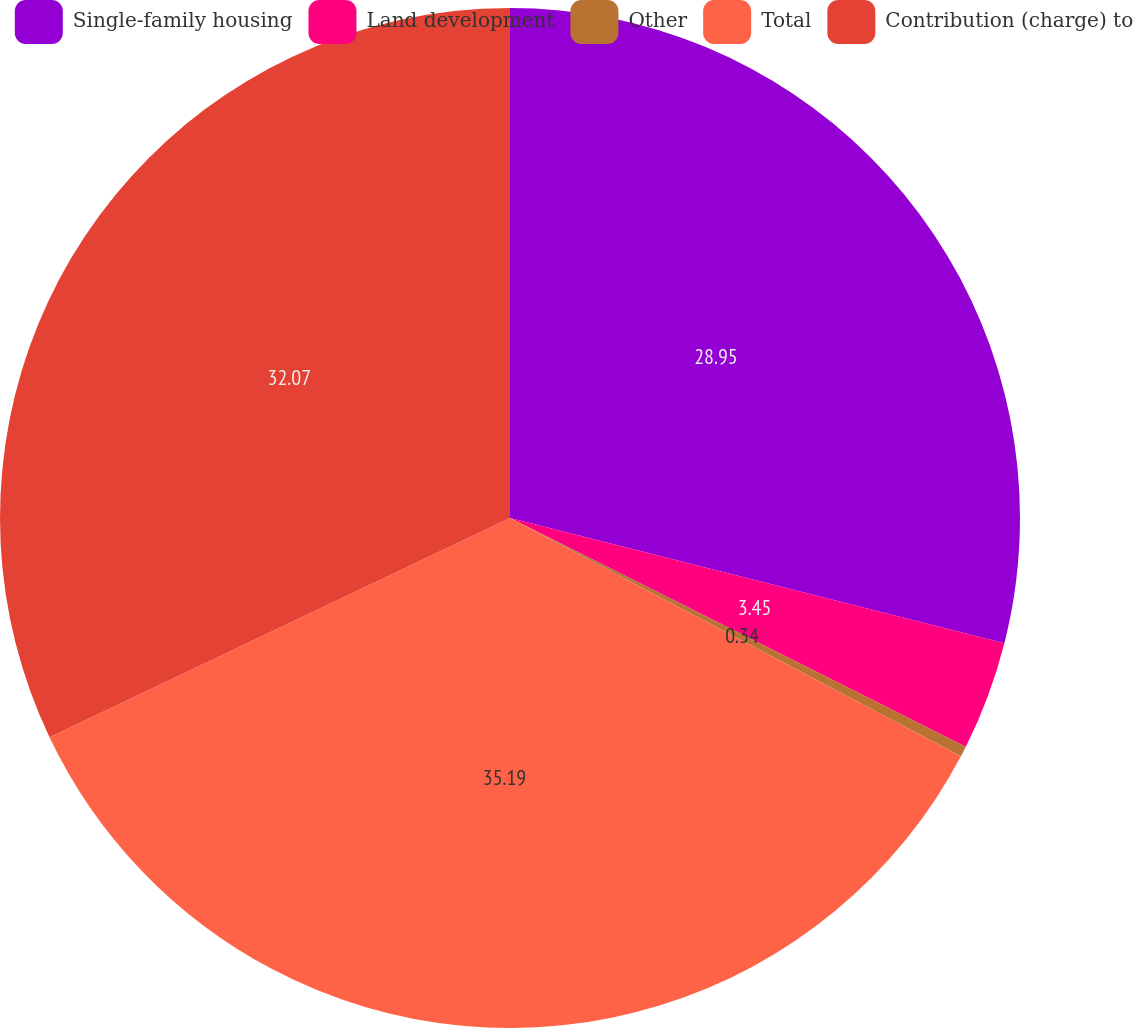<chart> <loc_0><loc_0><loc_500><loc_500><pie_chart><fcel>Single-family housing<fcel>Land development<fcel>Other<fcel>Total<fcel>Contribution (charge) to<nl><fcel>28.95%<fcel>3.45%<fcel>0.34%<fcel>35.19%<fcel>32.07%<nl></chart> 